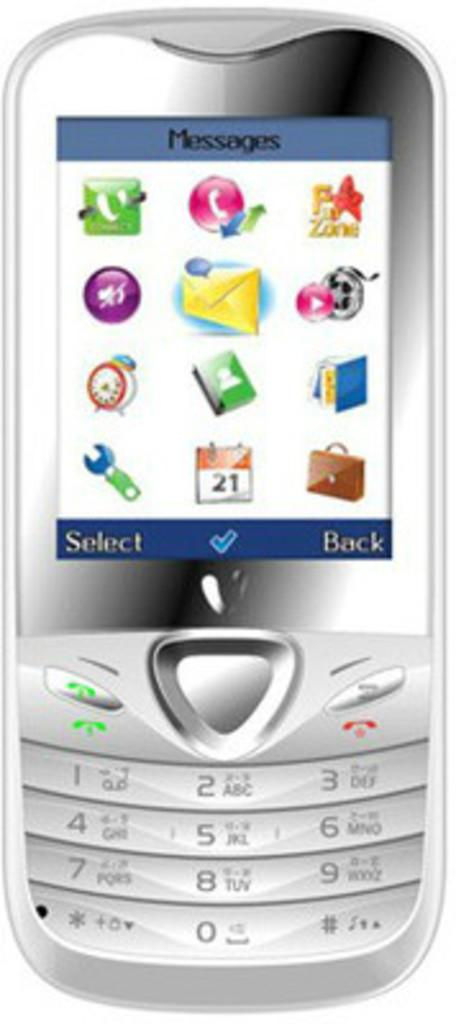Provide a one-sentence caption for the provided image. A silver cellphone with the top of the display screen saying Messages. 